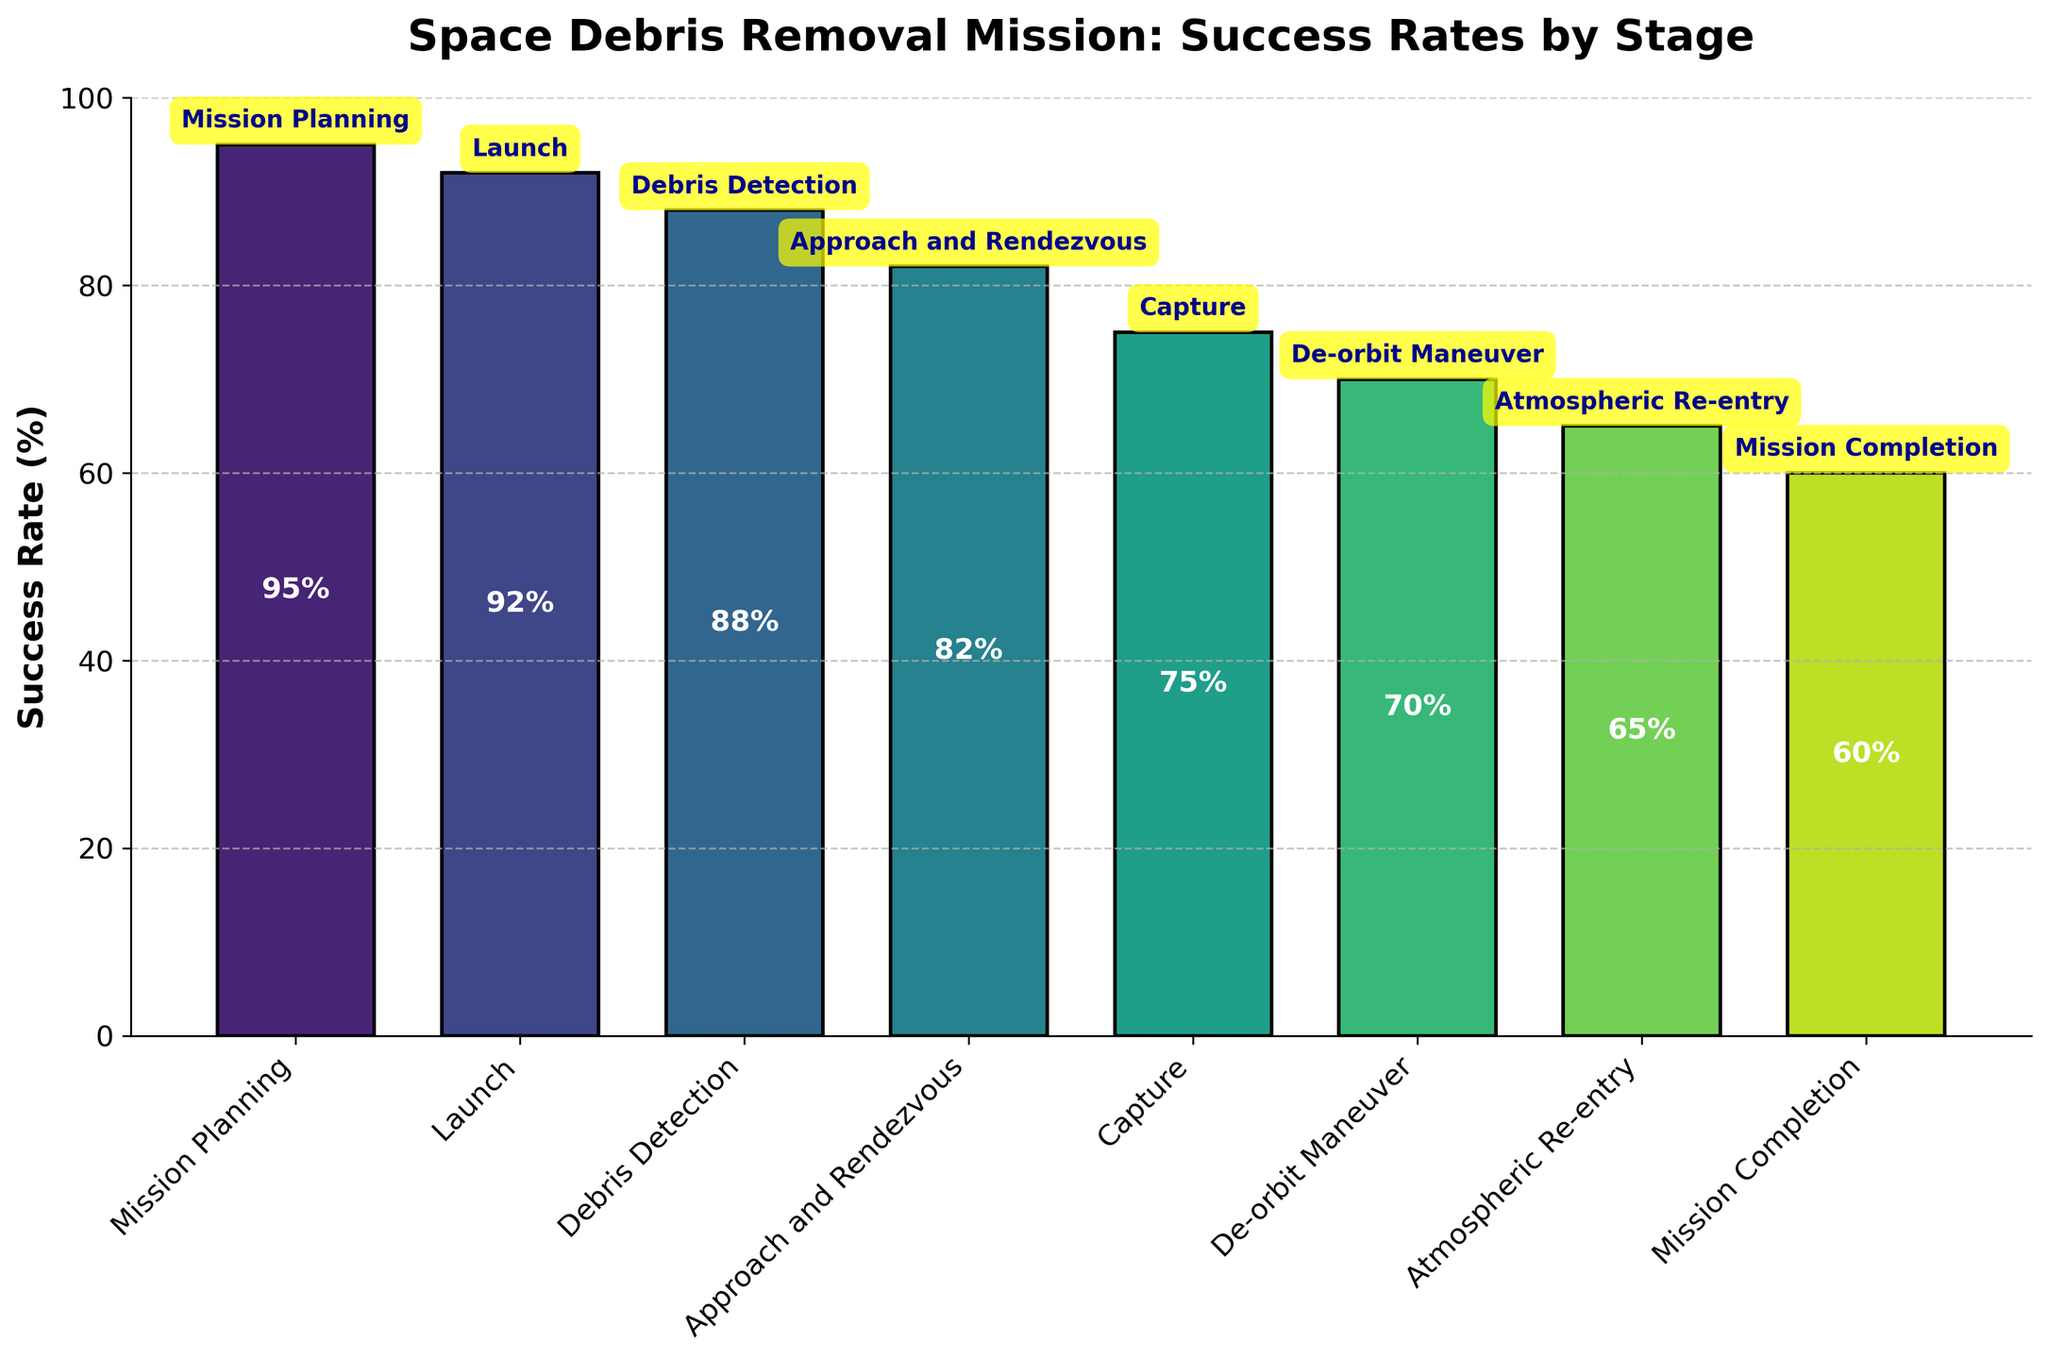What is the success rate of the 'Launch' stage? The success rate for each stage is provided by a label on the bar in the funnel chart. The 'Launch' stage has a success rate of 92%, as indicated by the label inside the bar.
Answer: 92% How does the success rate of 'Capture' compare to 'Mission Planning'? To compare the success rates, we look at the values labeled in the bars of the funnel chart. 'Capture' has a success rate of 75% and 'Mission Planning' has a success rate of 95%. By comparing these two, 'Capture' has a lower success rate than 'Mission Planning'.
Answer: Capture is lower Which stage has the lowest success rate? The lowest success rate can be identified by finding the smallest percentage labeled inside the bars on the funnel chart. 'Mission Completion' has the lowest success rate at 60%.
Answer: Mission Completion What is the difference in success rate between 'Debris Detection' and 'Approach and Rendezvous'? To find the difference, note the success rates for 'Debris Detection' (88%) and 'Approach and Rendezvous' (82%) from their respective bars in the funnel chart. Subtract the success rate of 'Approach and Rendezvous' from 'Debris Detection': 88% - 82% = 6%.
Answer: 6% What is the average success rate of the stages 'Launch', 'Debris Detection', and 'Capture'? First, identify the success rates of each stage: 'Launch' (92%), 'Debris Detection' (88%), and 'Capture' (75%). Then, sum these rates: 92% + 88% + 75% = 255%. Finally, divide by the number of stages (3): 255% / 3 = 85%.
Answer: 85% What is the title of the chart? The title is displayed at the top of the funnel chart. It reads 'Space Debris Removal Mission: Success Rates by Stage'.
Answer: Space Debris Removal Mission: Success Rates by Stage Which two consecutive stages have the greatest drop in success rate? To determine the greatest drop, compare the differences between consecutive stages. The drops are:
- 'Mission Planning' to 'Launch': 95% - 92% = 3%
- 'Launch' to 'Debris Detection': 92% - 88% = 4%
- 'Debris Detection' to 'Approach and Rendezvous': 88% - 82% = 6%
- 'Approach and Rendezvous' to 'Capture': 82% - 75% = 7%
- 'Capture' to 'De-orbit Maneuver': 75% - 70% = 5%
- 'De-orbit Maneuver' to 'Atmospheric Re-entry': 70% - 65% = 5%
- 'Atmospheric Re-entry' to 'Mission Completion': 65% - 60% = 5%
The greatest drop is between 'Approach and Rendezvous' and 'Capture', with a difference of 7%.
Answer: Approach and Rendezvous to Capture Is the success rate of 'De-orbit Maneuver' more than two-thirds but less than three-quarters? To determine if 'De-orbit Maneuver' falls in this range, calculate two-thirds (2/3) of 100%, which is approximately 66.67%, and three-quarters (3/4), which is 75%. The success rate for 'De-orbit Maneuver' is 70%, which falls between 66.67% and 75%.
Answer: Yes By how much does the success rate decrease from 'Atmospheric Re-entry' to 'Mission Completion'? The success rate for 'Atmospheric Re-entry' is 65%, and for 'Mission Completion' it is 60%. To find the decrease, subtract the latter from the former: 65% - 60% = 5%.
Answer: 5% 